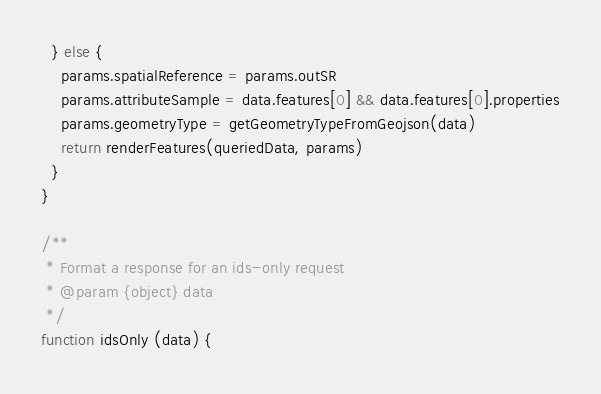Convert code to text. <code><loc_0><loc_0><loc_500><loc_500><_JavaScript_>  } else {
    params.spatialReference = params.outSR
    params.attributeSample = data.features[0] && data.features[0].properties
    params.geometryType = getGeometryTypeFromGeojson(data)
    return renderFeatures(queriedData, params)
  }
}

/**
 * Format a response for an ids-only request
 * @param {object} data
 */
function idsOnly (data) {</code> 